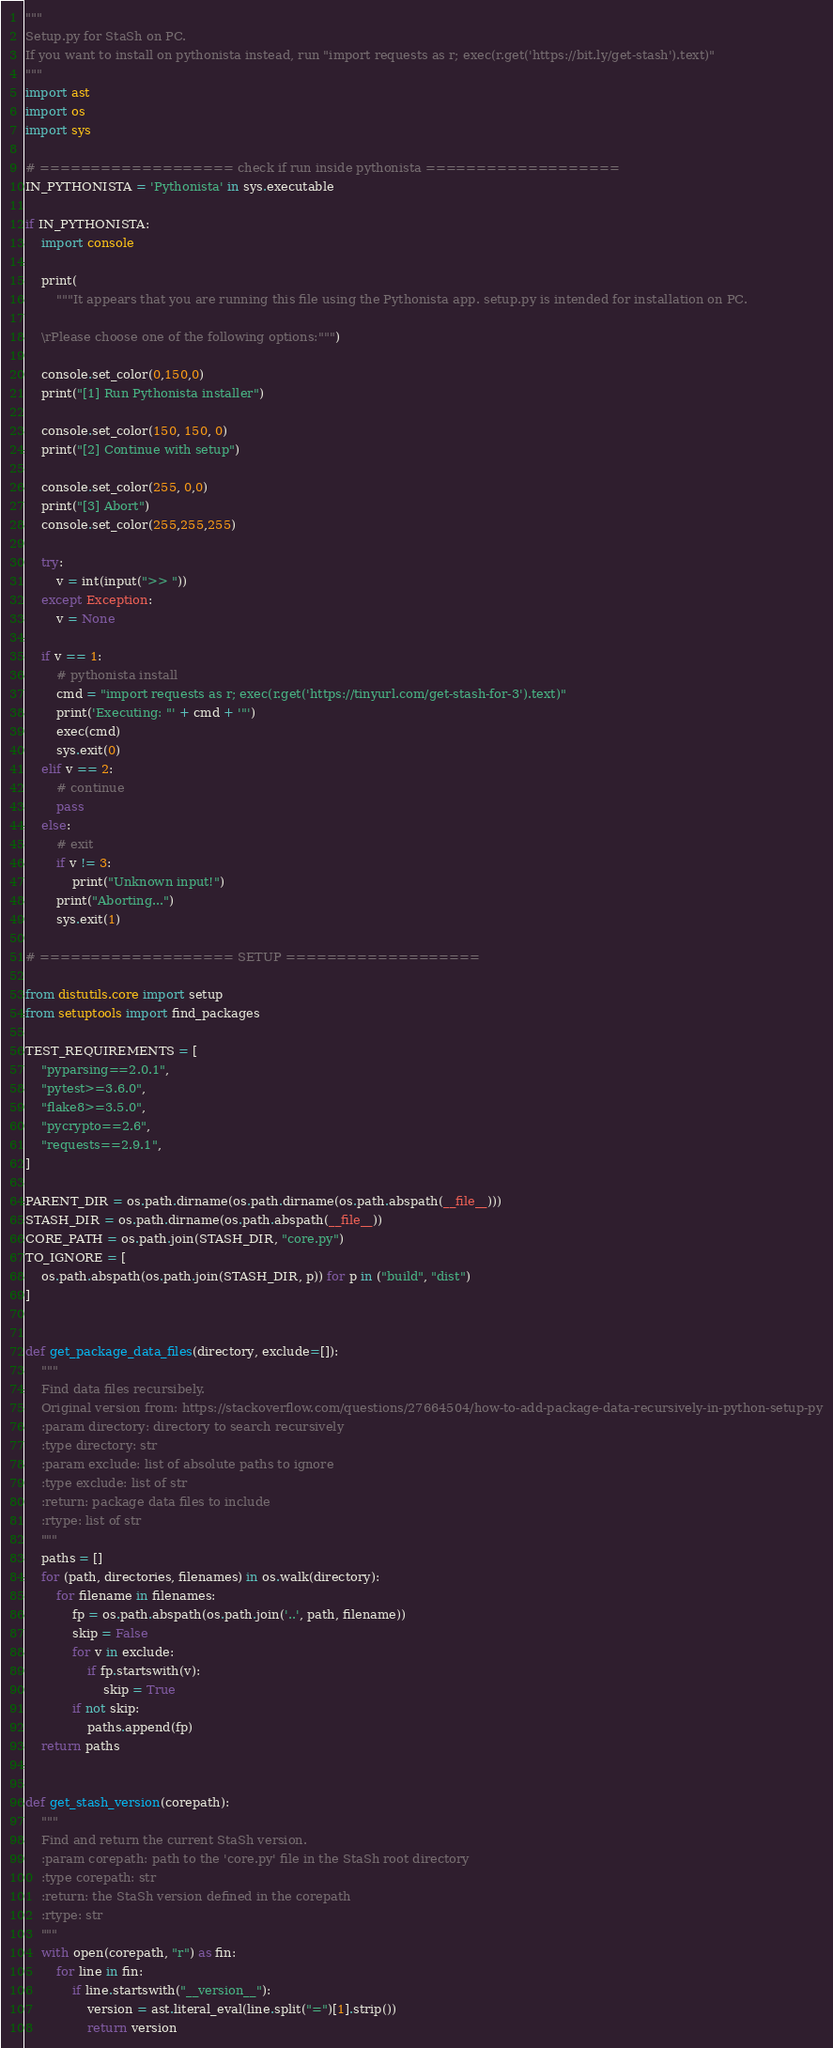Convert code to text. <code><loc_0><loc_0><loc_500><loc_500><_Python_>"""
Setup.py for StaSh on PC.
If you want to install on pythonista instead, run "import requests as r; exec(r.get('https://bit.ly/get-stash').text)"
"""
import ast
import os
import sys

# =================== check if run inside pythonista ===================
IN_PYTHONISTA = 'Pythonista' in sys.executable

if IN_PYTHONISTA:
    import console

    print(
        """It appears that you are running this file using the Pythonista app. setup.py is intended for installation on PC.

    \rPlease choose one of the following options:""")
   
    console.set_color(0,150,0)
    print("[1] Run Pythonista installer")
    
    console.set_color(150, 150, 0)
    print("[2] Continue with setup")
    
    console.set_color(255, 0,0)
    print("[3] Abort")
    console.set_color(255,255,255)
    
    try:
        v = int(input(">> "))
    except Exception:
        v = None
    
    if v == 1:
        # pythonista install
        cmd = "import requests as r; exec(r.get('https://tinyurl.com/get-stash-for-3').text)"
        print('Executing: "' + cmd + '"')
        exec(cmd)
        sys.exit(0)
    elif v == 2:
        # continue
        pass
    else:
        # exit
        if v != 3:
            print("Unknown input!")
        print("Aborting...")
        sys.exit(1)

# =================== SETUP ===================

from distutils.core import setup
from setuptools import find_packages

TEST_REQUIREMENTS = [
    "pyparsing==2.0.1",
    "pytest>=3.6.0",
    "flake8>=3.5.0",
    "pycrypto==2.6",
    "requests==2.9.1",
]

PARENT_DIR = os.path.dirname(os.path.dirname(os.path.abspath(__file__)))
STASH_DIR = os.path.dirname(os.path.abspath(__file__))
CORE_PATH = os.path.join(STASH_DIR, "core.py")
TO_IGNORE = [
    os.path.abspath(os.path.join(STASH_DIR, p)) for p in ("build", "dist")
]


def get_package_data_files(directory, exclude=[]):
    """
    Find data files recursibely.
    Original version from: https://stackoverflow.com/questions/27664504/how-to-add-package-data-recursively-in-python-setup-py
    :param directory: directory to search recursively
    :type directory: str
    :param exclude: list of absolute paths to ignore
    :type exclude: list of str
    :return: package data files to include
    :rtype: list of str
    """
    paths = []
    for (path, directories, filenames) in os.walk(directory):
        for filename in filenames:
            fp = os.path.abspath(os.path.join('..', path, filename))
            skip = False
            for v in exclude:
                if fp.startswith(v):
                    skip = True
            if not skip:
                paths.append(fp)
    return paths


def get_stash_version(corepath):
    """
    Find and return the current StaSh version.
    :param corepath: path to the 'core.py' file in the StaSh root directory
    :type corepath: str
    :return: the StaSh version defined in the corepath
    :rtype: str
    """
    with open(corepath, "r") as fin:
        for line in fin:
            if line.startswith("__version__"):
                version = ast.literal_eval(line.split("=")[1].strip())
                return version</code> 